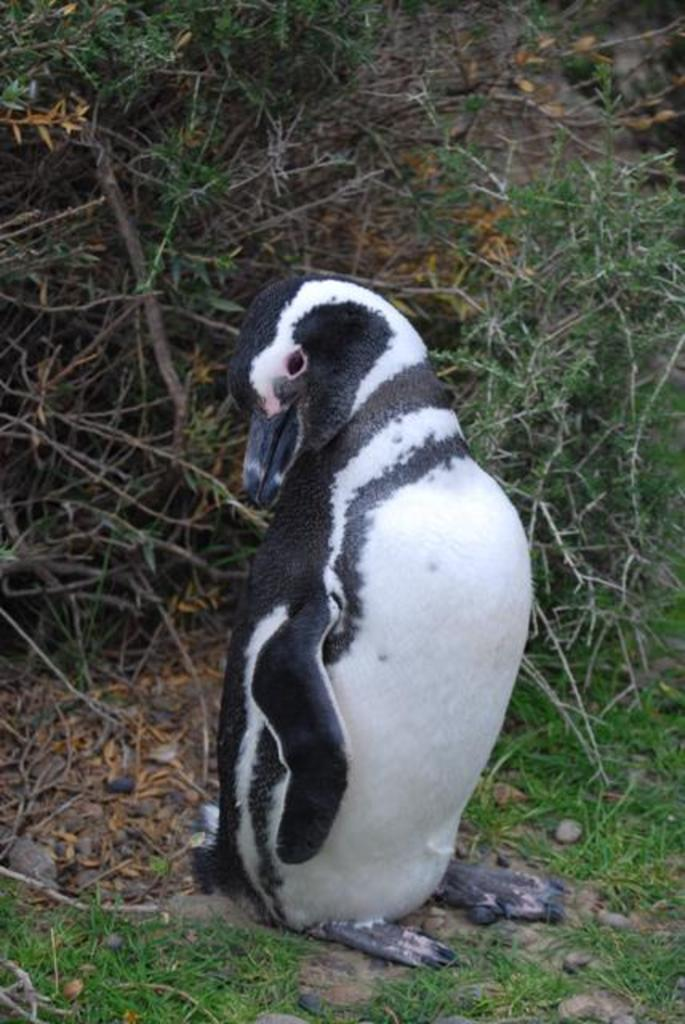What type of animal is in the image? There is a penguin in the image. What is the penguin standing on in the image? The penguin is on grass in the image. What other living organisms can be seen in the image? There are plants in the image. Can you tell if the image was taken during the day or night? The image was likely taken during the day, as there is no indication of darkness or artificial lighting. What type of insurance does the penguin have in the image? There is no indication of insurance in the image; it features a penguin standing on grass with plants nearby. 